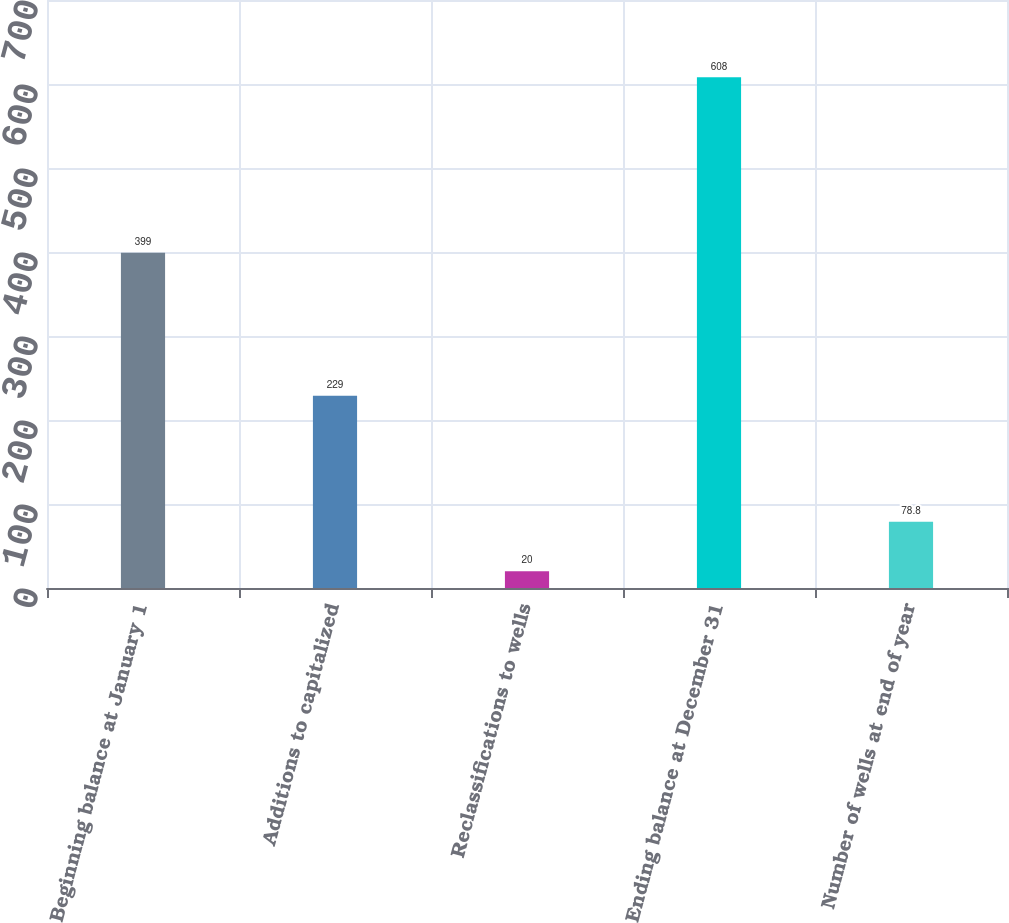Convert chart to OTSL. <chart><loc_0><loc_0><loc_500><loc_500><bar_chart><fcel>Beginning balance at January 1<fcel>Additions to capitalized<fcel>Reclassifications to wells<fcel>Ending balance at December 31<fcel>Number of wells at end of year<nl><fcel>399<fcel>229<fcel>20<fcel>608<fcel>78.8<nl></chart> 